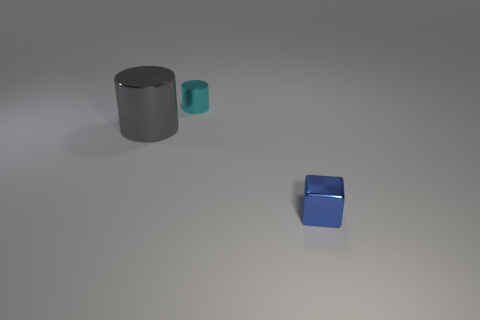Add 3 small shiny objects. How many objects exist? 6 Subtract all cylinders. How many objects are left? 1 Add 3 small metallic cubes. How many small metallic cubes are left? 4 Add 3 brown blocks. How many brown blocks exist? 3 Subtract 0 red spheres. How many objects are left? 3 Subtract all tiny red cylinders. Subtract all tiny blue cubes. How many objects are left? 2 